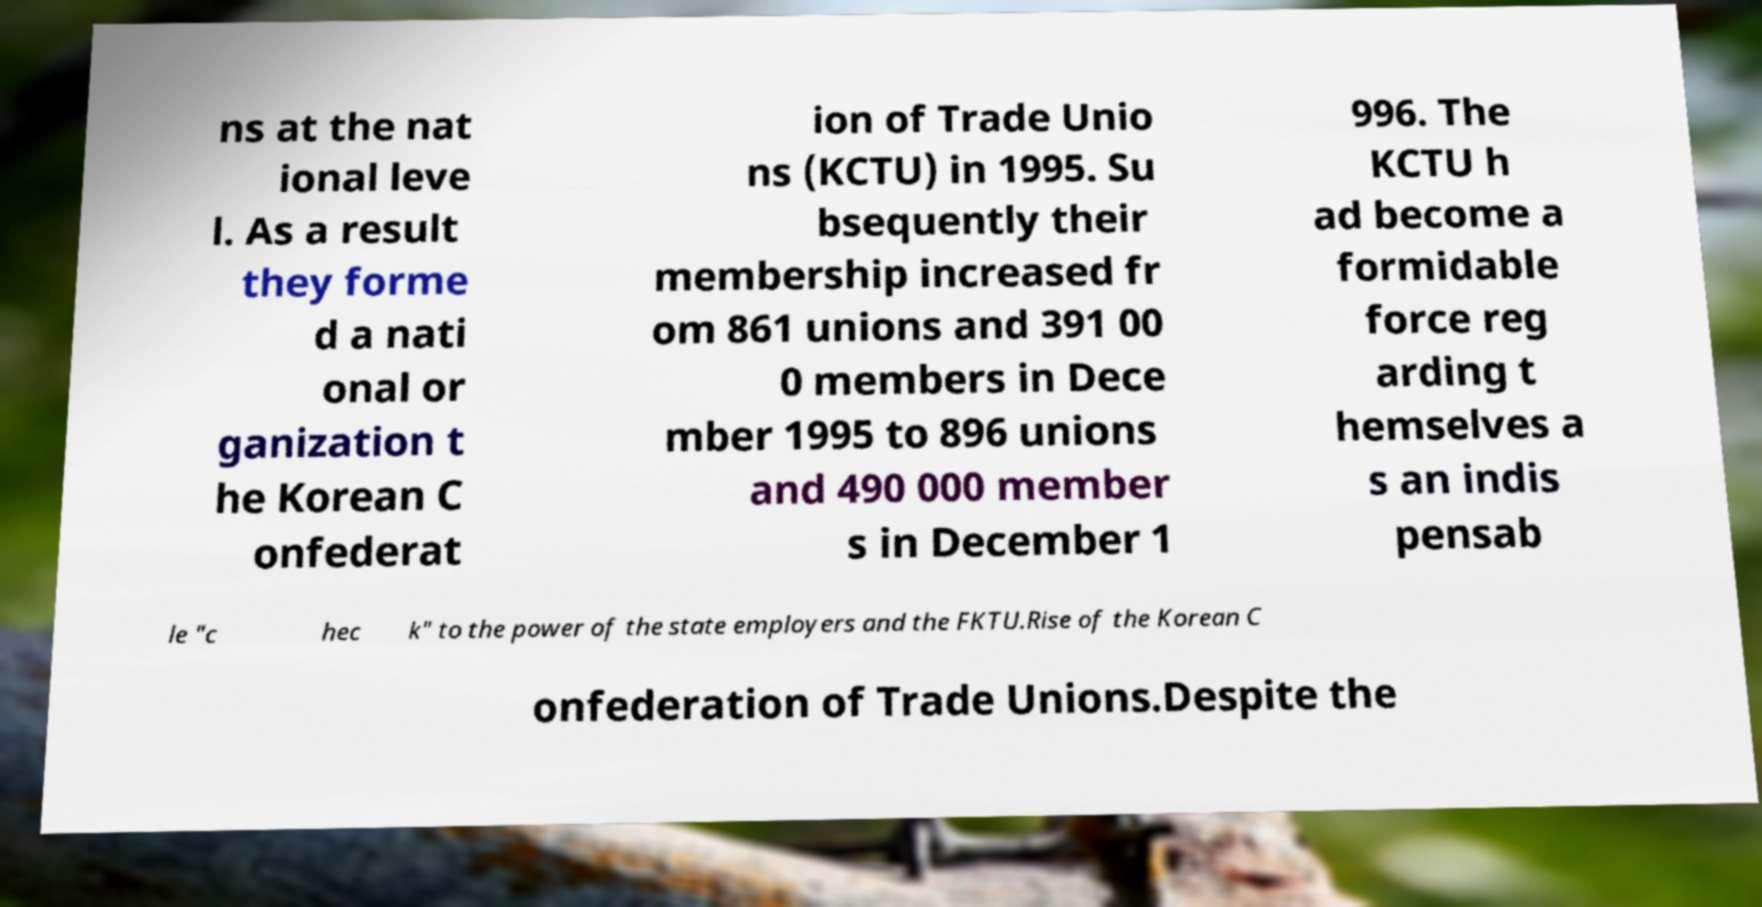I need the written content from this picture converted into text. Can you do that? ns at the nat ional leve l. As a result they forme d a nati onal or ganization t he Korean C onfederat ion of Trade Unio ns (KCTU) in 1995. Su bsequently their membership increased fr om 861 unions and 391 00 0 members in Dece mber 1995 to 896 unions and 490 000 member s in December 1 996. The KCTU h ad become a formidable force reg arding t hemselves a s an indis pensab le "c hec k" to the power of the state employers and the FKTU.Rise of the Korean C onfederation of Trade Unions.Despite the 